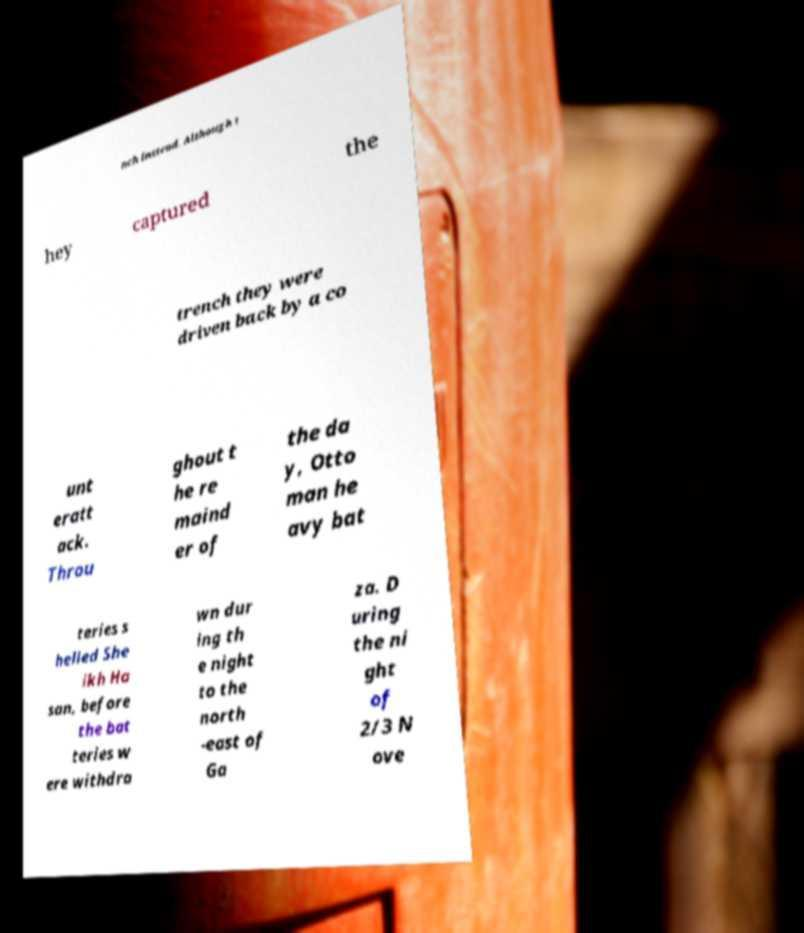I need the written content from this picture converted into text. Can you do that? nch instead. Although t hey captured the trench they were driven back by a co unt eratt ack. Throu ghout t he re maind er of the da y, Otto man he avy bat teries s helled She ikh Ha san, before the bat teries w ere withdra wn dur ing th e night to the north -east of Ga za. D uring the ni ght of 2/3 N ove 